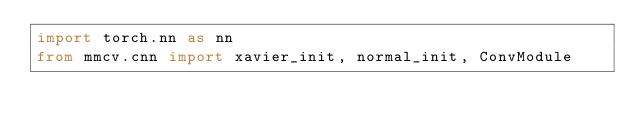Convert code to text. <code><loc_0><loc_0><loc_500><loc_500><_Python_>import torch.nn as nn
from mmcv.cnn import xavier_init, normal_init, ConvModule
</code> 